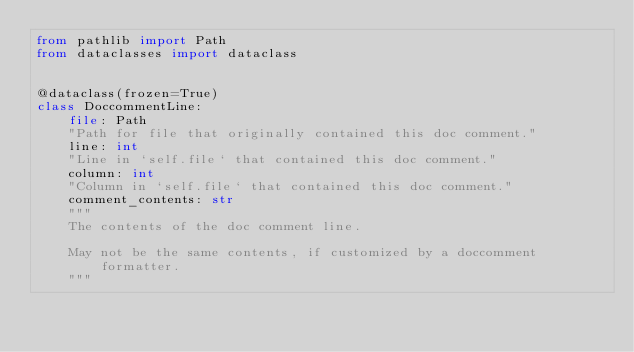Convert code to text. <code><loc_0><loc_0><loc_500><loc_500><_Python_>from pathlib import Path
from dataclasses import dataclass


@dataclass(frozen=True)
class DoccommentLine:
    file: Path
    "Path for file that originally contained this doc comment."
    line: int
    "Line in `self.file` that contained this doc comment."
    column: int
    "Column in `self.file` that contained this doc comment."
    comment_contents: str
    """
    The contents of the doc comment line.
    
    May not be the same contents, if customized by a doccomment formatter.
    """
</code> 